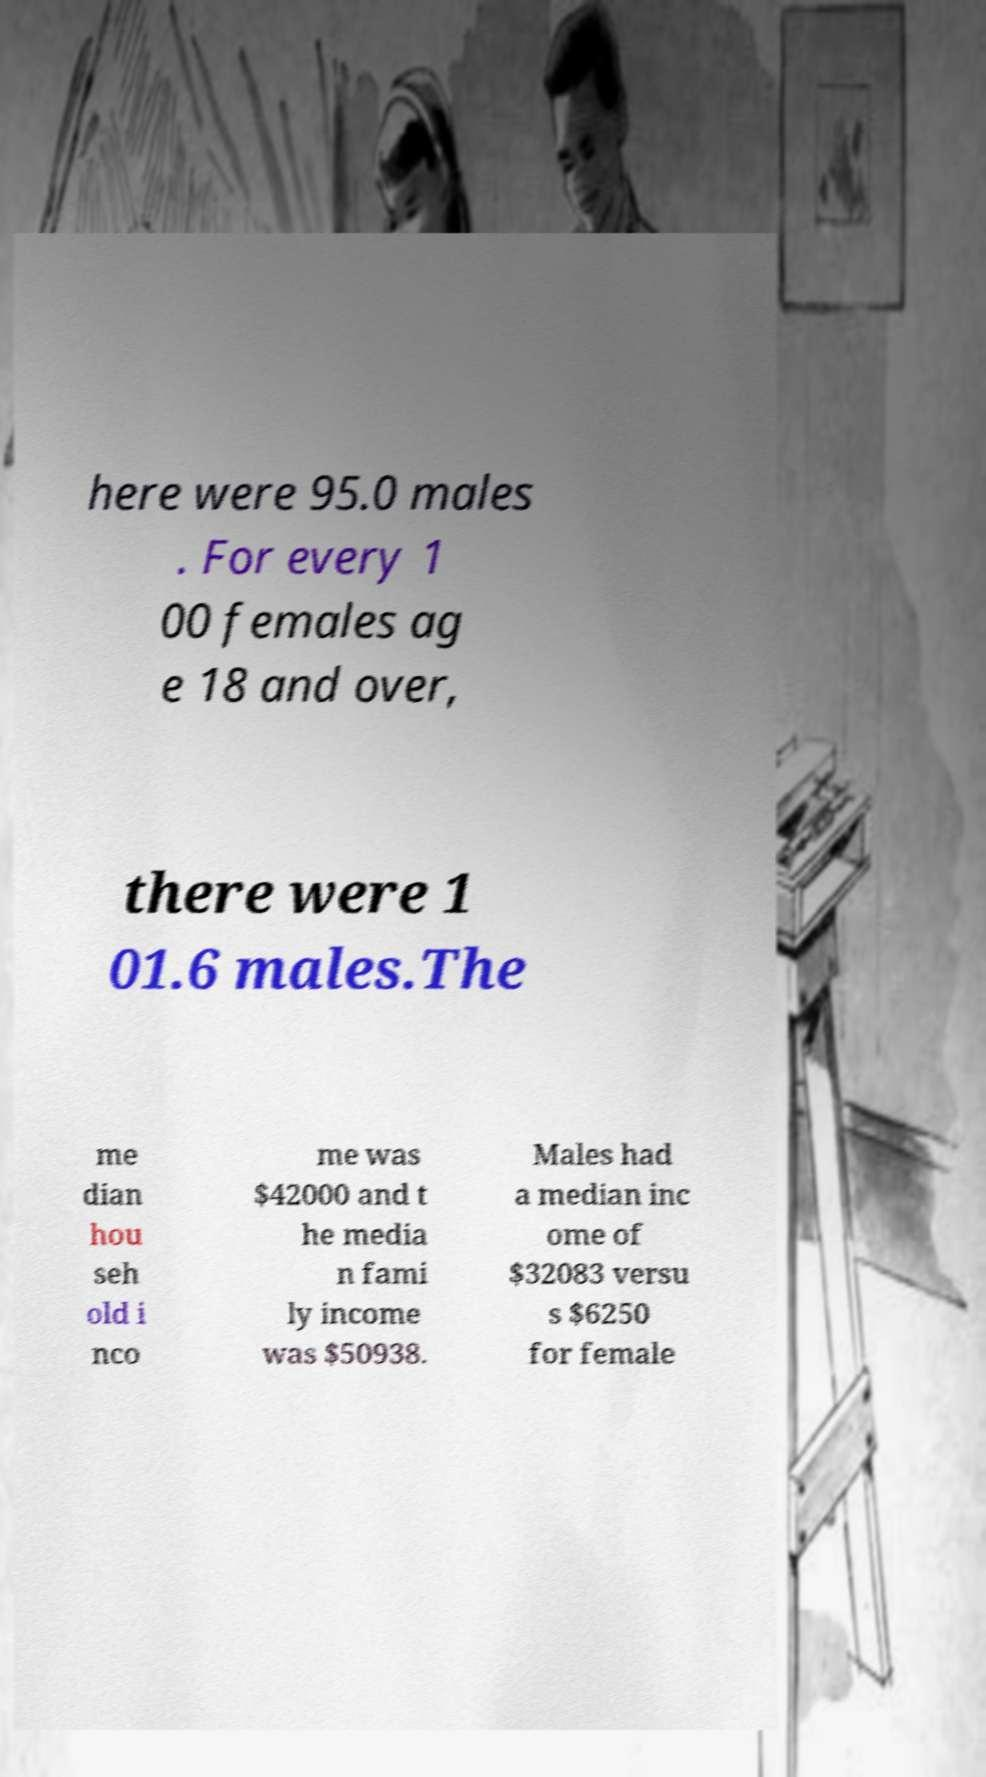Could you extract and type out the text from this image? here were 95.0 males . For every 1 00 females ag e 18 and over, there were 1 01.6 males.The me dian hou seh old i nco me was $42000 and t he media n fami ly income was $50938. Males had a median inc ome of $32083 versu s $6250 for female 